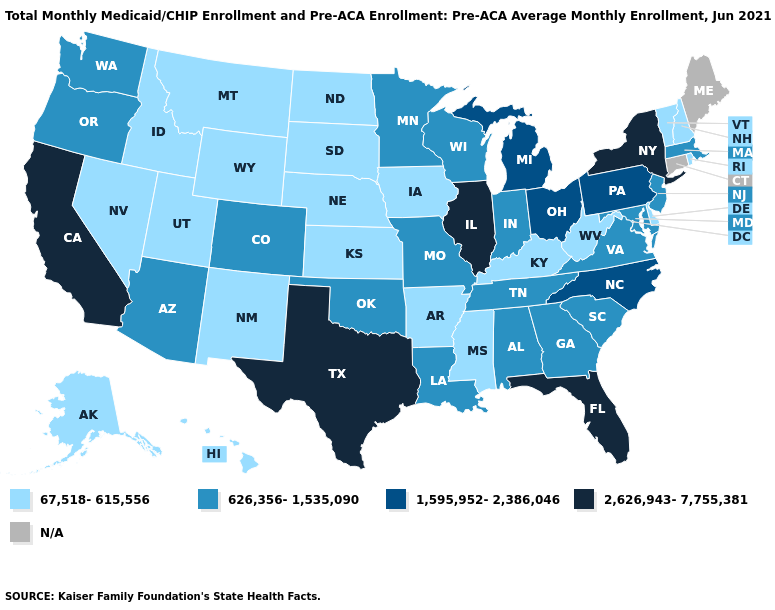What is the value of South Dakota?
Be succinct. 67,518-615,556. What is the highest value in the USA?
Answer briefly. 2,626,943-7,755,381. What is the value of North Dakota?
Answer briefly. 67,518-615,556. What is the value of Georgia?
Answer briefly. 626,356-1,535,090. What is the highest value in the USA?
Quick response, please. 2,626,943-7,755,381. Does Vermont have the lowest value in the Northeast?
Answer briefly. Yes. Which states have the highest value in the USA?
Short answer required. California, Florida, Illinois, New York, Texas. Does Idaho have the lowest value in the USA?
Keep it brief. Yes. Does Delaware have the lowest value in the USA?
Keep it brief. Yes. What is the value of Washington?
Concise answer only. 626,356-1,535,090. What is the value of New York?
Short answer required. 2,626,943-7,755,381. Among the states that border Virginia , which have the highest value?
Write a very short answer. North Carolina. What is the value of Arizona?
Answer briefly. 626,356-1,535,090. What is the lowest value in the MidWest?
Keep it brief. 67,518-615,556. 